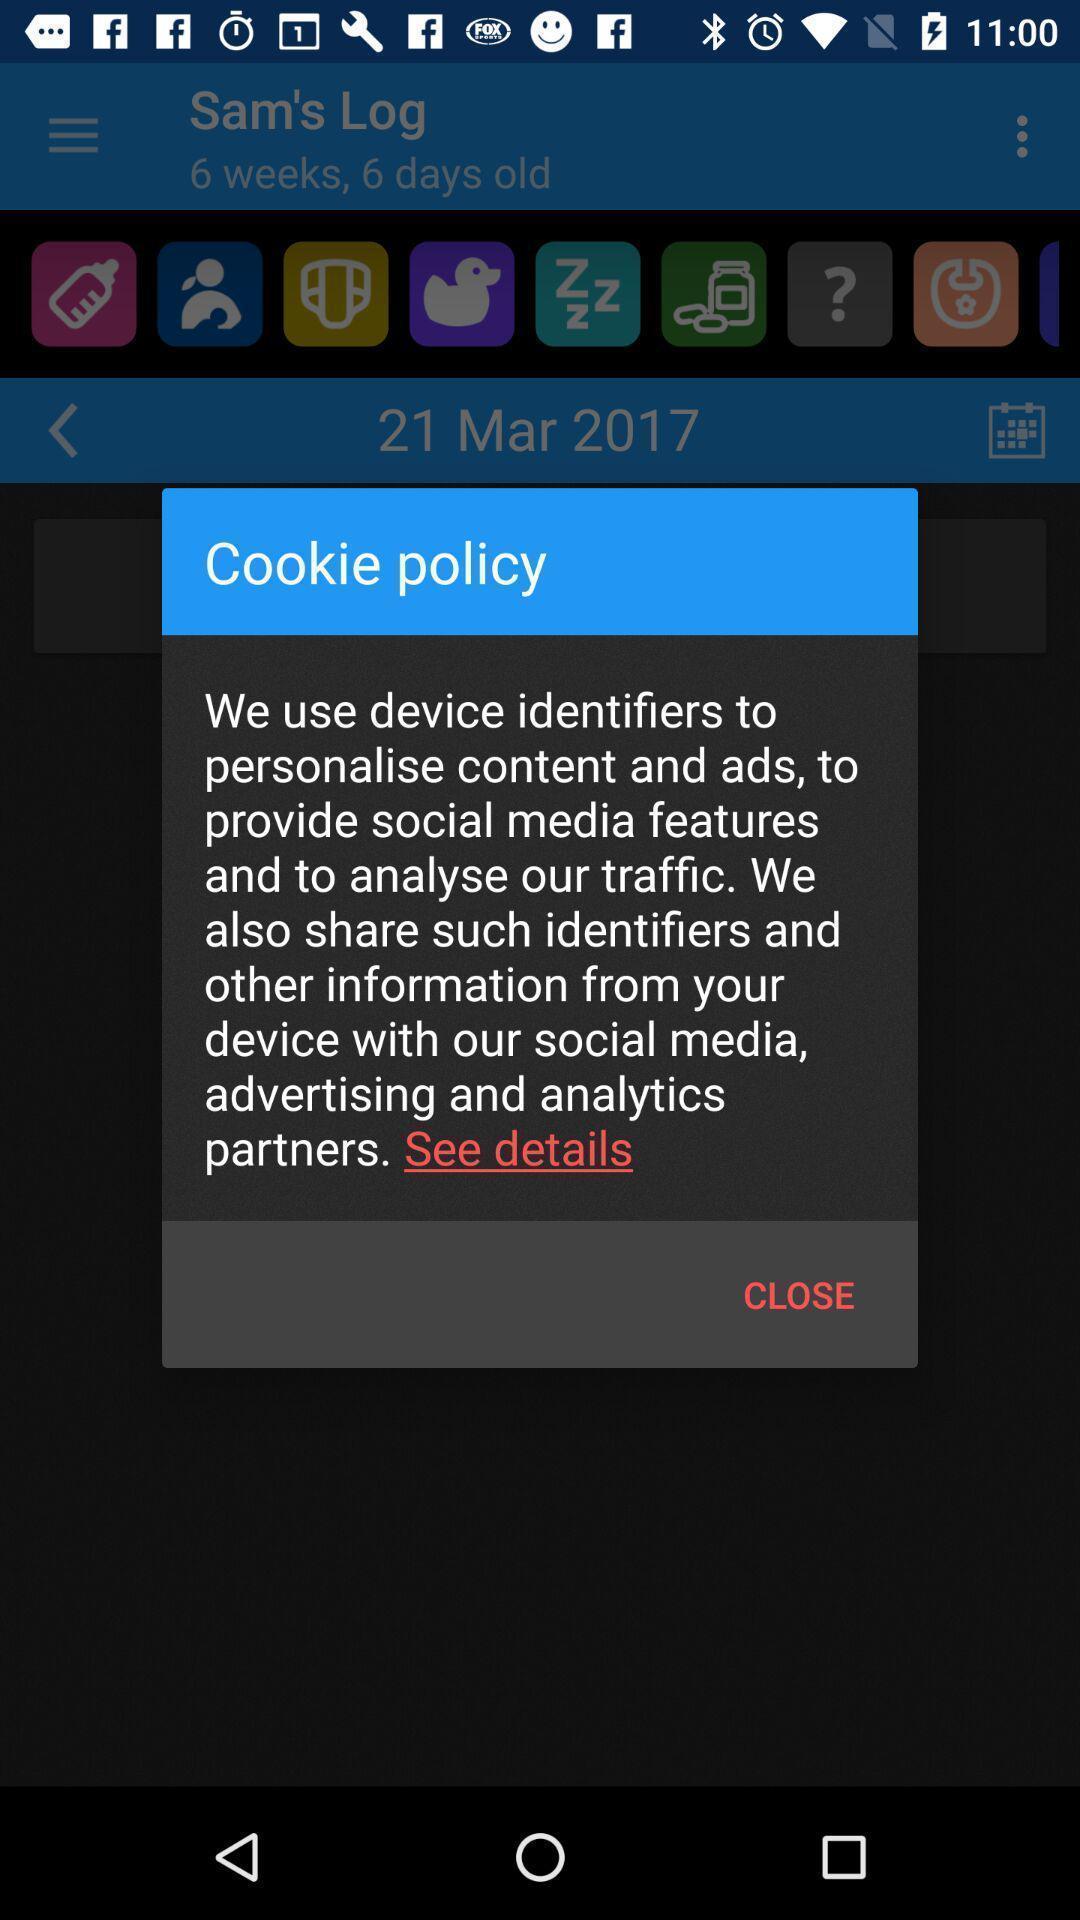What details can you identify in this image? Pop-up displaying the cookie policy in a social app. 